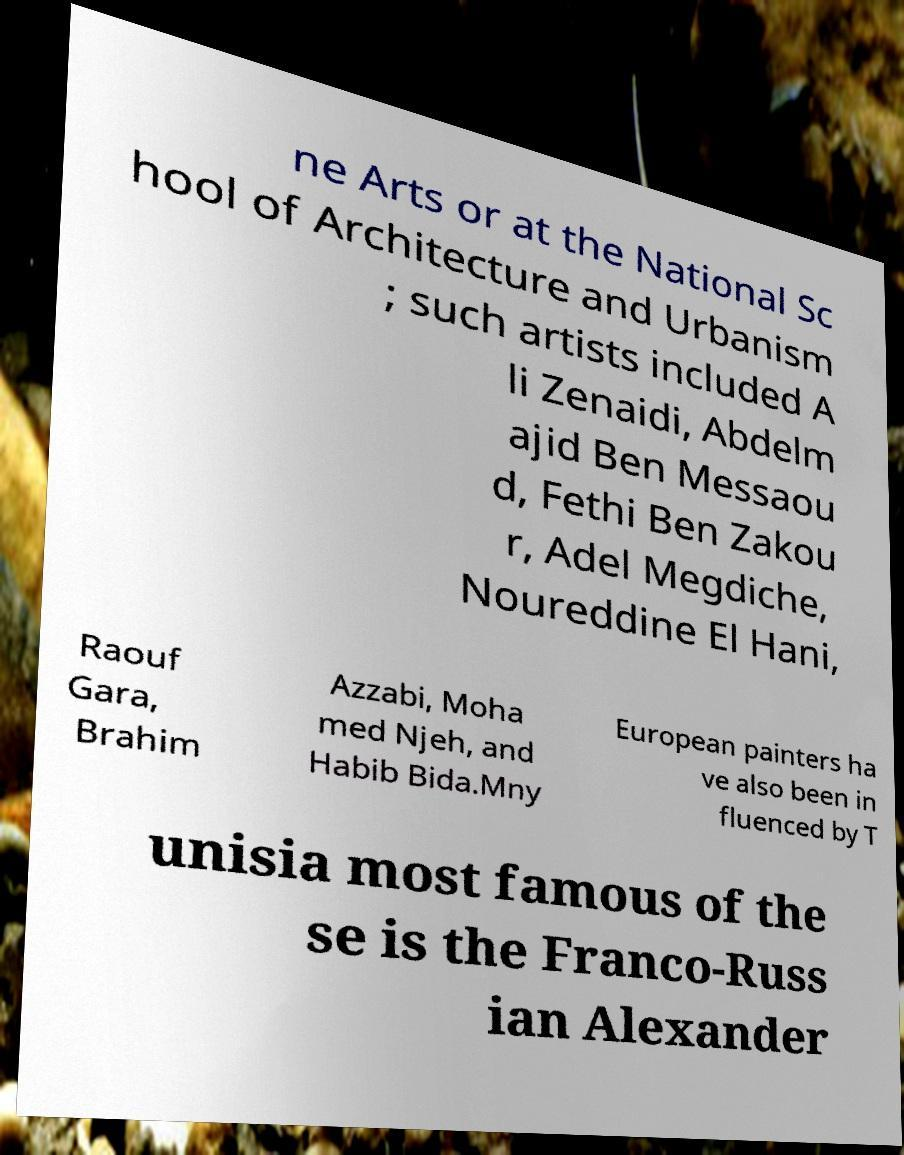Please read and relay the text visible in this image. What does it say? ne Arts or at the National Sc hool of Architecture and Urbanism ; such artists included A li Zenaidi, Abdelm ajid Ben Messaou d, Fethi Ben Zakou r, Adel Megdiche, Noureddine El Hani, Raouf Gara, Brahim Azzabi, Moha med Njeh, and Habib Bida.Mny European painters ha ve also been in fluenced by T unisia most famous of the se is the Franco-Russ ian Alexander 